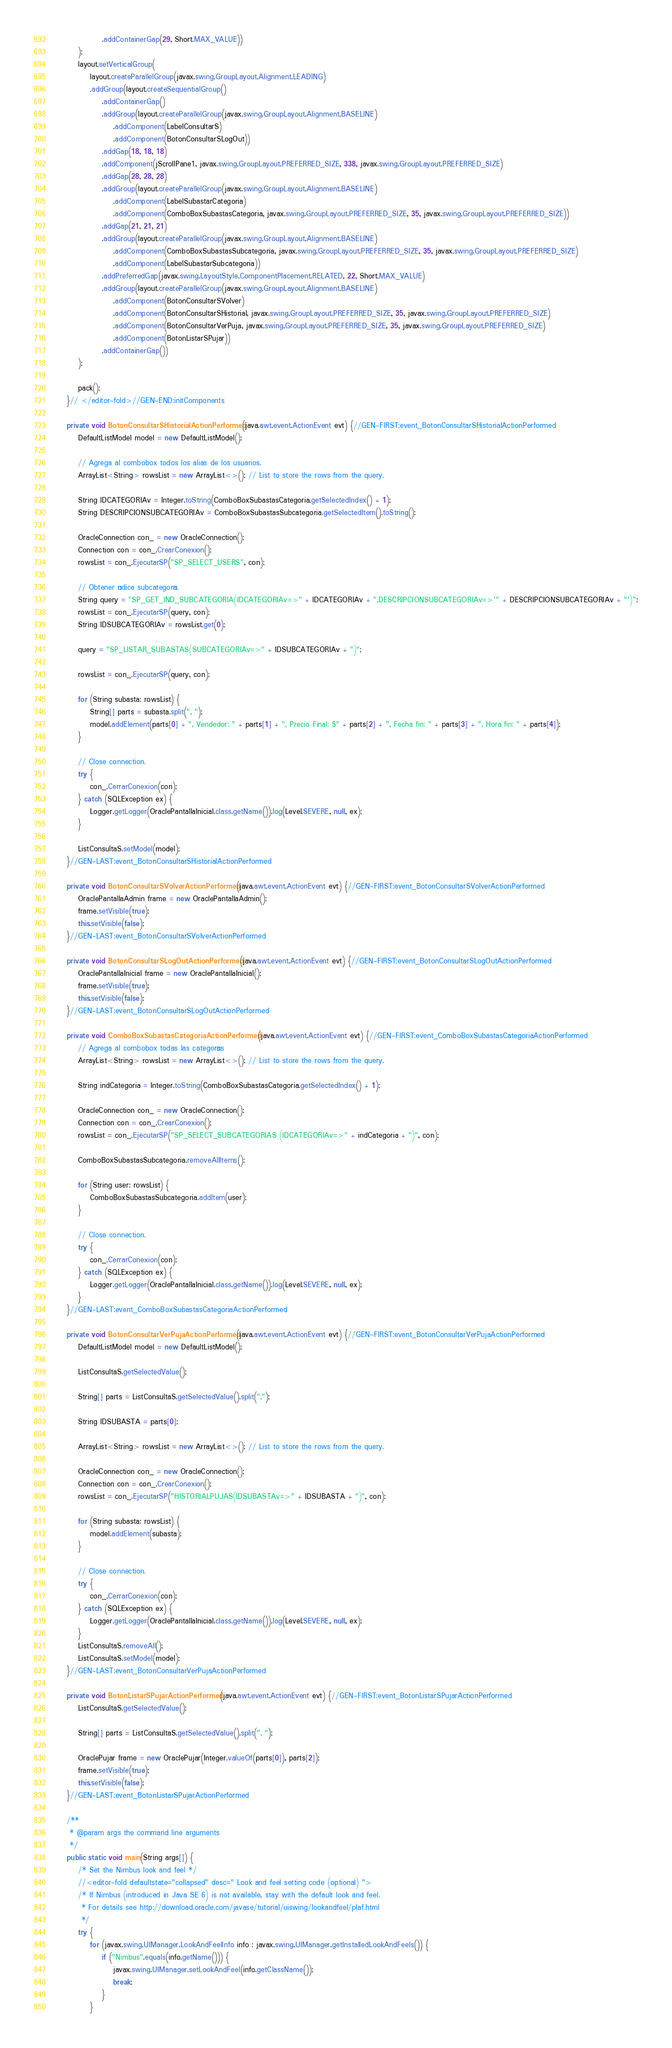Convert code to text. <code><loc_0><loc_0><loc_500><loc_500><_Java_>                .addContainerGap(29, Short.MAX_VALUE))
        );
        layout.setVerticalGroup(
            layout.createParallelGroup(javax.swing.GroupLayout.Alignment.LEADING)
            .addGroup(layout.createSequentialGroup()
                .addContainerGap()
                .addGroup(layout.createParallelGroup(javax.swing.GroupLayout.Alignment.BASELINE)
                    .addComponent(LabelConsultarS)
                    .addComponent(BotonConsultarSLogOut))
                .addGap(18, 18, 18)
                .addComponent(jScrollPane1, javax.swing.GroupLayout.PREFERRED_SIZE, 338, javax.swing.GroupLayout.PREFERRED_SIZE)
                .addGap(28, 28, 28)
                .addGroup(layout.createParallelGroup(javax.swing.GroupLayout.Alignment.BASELINE)
                    .addComponent(LabelSubastarCategoria)
                    .addComponent(ComboBoxSubastasCategoria, javax.swing.GroupLayout.PREFERRED_SIZE, 35, javax.swing.GroupLayout.PREFERRED_SIZE))
                .addGap(21, 21, 21)
                .addGroup(layout.createParallelGroup(javax.swing.GroupLayout.Alignment.BASELINE)
                    .addComponent(ComboBoxSubastasSubcategoria, javax.swing.GroupLayout.PREFERRED_SIZE, 35, javax.swing.GroupLayout.PREFERRED_SIZE)
                    .addComponent(LabelSubastarSubcategoria))
                .addPreferredGap(javax.swing.LayoutStyle.ComponentPlacement.RELATED, 22, Short.MAX_VALUE)
                .addGroup(layout.createParallelGroup(javax.swing.GroupLayout.Alignment.BASELINE)
                    .addComponent(BotonConsultarSVolver)
                    .addComponent(BotonConsultarSHistorial, javax.swing.GroupLayout.PREFERRED_SIZE, 35, javax.swing.GroupLayout.PREFERRED_SIZE)
                    .addComponent(BotonConsultarVerPuja, javax.swing.GroupLayout.PREFERRED_SIZE, 35, javax.swing.GroupLayout.PREFERRED_SIZE)
                    .addComponent(BotonListarSPujar))
                .addContainerGap())
        );

        pack();
    }// </editor-fold>//GEN-END:initComponents

    private void BotonConsultarSHistorialActionPerformed(java.awt.event.ActionEvent evt) {//GEN-FIRST:event_BotonConsultarSHistorialActionPerformed
        DefaultListModel model = new DefaultListModel();
        
        // Agrega al combobox todos los alias de los usuarios.
        ArrayList<String> rowsList = new ArrayList<>(); // List to store the rows from the query.
        
        String IDCATEGORIAv = Integer.toString(ComboBoxSubastasCategoria.getSelectedIndex() + 1);
        String DESCRIPCIONSUBCATEGORIAv = ComboBoxSubastasSubcategoria.getSelectedItem().toString();
        
        OracleConnection con_ = new OracleConnection();
        Connection con = con_.CrearConexion();
        rowsList = con_.EjecutarSP("SP_SELECT_USERS", con);
        
        // Obtener índice subcategoría.
        String query = "SP_GET_IND_SUBCATEGORIA(IDCATEGORIAv=>" + IDCATEGORIAv + ",DESCRIPCIONSUBCATEGORIAv=>'" + DESCRIPCIONSUBCATEGORIAv + "')";
        rowsList = con_.EjecutarSP(query, con);
        String IDSUBCATEGORIAv = rowsList.get(0);
        
        query = "SP_LISTAR_SUBASTAS(SUBCATEGORIAv=>" + IDSUBCATEGORIAv + ")";
 
        rowsList = con_.EjecutarSP(query, con);
        
        for (String subasta: rowsList) {
            String[] parts = subasta.split(", ");
            model.addElement(parts[0] + ", Vendedor: " + parts[1] + ", Precio Final: $" + parts[2] + ", Fecha fin: " + parts[3] + ", Hora fin: " + parts[4]);
        }
        
        // Close connection.
        try {
            con_.CerrarConexion(con);
        } catch (SQLException ex) {
            Logger.getLogger(OraclePantallaInicial.class.getName()).log(Level.SEVERE, null, ex);
        }
        
        ListConsultaS.setModel(model);
    }//GEN-LAST:event_BotonConsultarSHistorialActionPerformed

    private void BotonConsultarSVolverActionPerformed(java.awt.event.ActionEvent evt) {//GEN-FIRST:event_BotonConsultarSVolverActionPerformed
        OraclePantallaAdmin frame = new OraclePantallaAdmin();
        frame.setVisible(true);
        this.setVisible(false);
    }//GEN-LAST:event_BotonConsultarSVolverActionPerformed

    private void BotonConsultarSLogOutActionPerformed(java.awt.event.ActionEvent evt) {//GEN-FIRST:event_BotonConsultarSLogOutActionPerformed
        OraclePantallaInicial frame = new OraclePantallaInicial();
        frame.setVisible(true);
        this.setVisible(false);
    }//GEN-LAST:event_BotonConsultarSLogOutActionPerformed

    private void ComboBoxSubastasCategoriaActionPerformed(java.awt.event.ActionEvent evt) {//GEN-FIRST:event_ComboBoxSubastasCategoriaActionPerformed
        // Agrega al combobox todas las categorías
        ArrayList<String> rowsList = new ArrayList<>(); // List to store the rows from the query.

        String indCategoria = Integer.toString(ComboBoxSubastasCategoria.getSelectedIndex() + 1);

        OracleConnection con_ = new OracleConnection();
        Connection con = con_.CrearConexion();
        rowsList = con_.EjecutarSP("SP_SELECT_SUBCATEGORIAS (IDCATEGORIAv=>" + indCategoria + ")", con);

        ComboBoxSubastasSubcategoria.removeAllItems();

        for (String user: rowsList) {
            ComboBoxSubastasSubcategoria.addItem(user);
        }

        // Close connection.
        try {
            con_.CerrarConexion(con);
        } catch (SQLException ex) {
            Logger.getLogger(OraclePantallaInicial.class.getName()).log(Level.SEVERE, null, ex);
        }
    }//GEN-LAST:event_ComboBoxSubastasCategoriaActionPerformed

    private void BotonConsultarVerPujaActionPerformed(java.awt.event.ActionEvent evt) {//GEN-FIRST:event_BotonConsultarVerPujaActionPerformed
        DefaultListModel model = new DefaultListModel();
        
        ListConsultaS.getSelectedValue();
        
        String[] parts = ListConsultaS.getSelectedValue().split(",");
        
        String IDSUBASTA = parts[0];
        
        ArrayList<String> rowsList = new ArrayList<>(); // List to store the rows from the query.
        
        OracleConnection con_ = new OracleConnection();
        Connection con = con_.CrearConexion();
        rowsList = con_.EjecutarSP("HISTORIALPUJAS(IDSUBASTAv=>" + IDSUBASTA + ")", con);
        
        for (String subasta: rowsList) {
            model.addElement(subasta);
        }
        
        // Close connection.
        try {
            con_.CerrarConexion(con);
        } catch (SQLException ex) {
            Logger.getLogger(OraclePantallaInicial.class.getName()).log(Level.SEVERE, null, ex);
        }
        ListConsultaS.removeAll();
        ListConsultaS.setModel(model);
    }//GEN-LAST:event_BotonConsultarVerPujaActionPerformed

    private void BotonListarSPujarActionPerformed(java.awt.event.ActionEvent evt) {//GEN-FIRST:event_BotonListarSPujarActionPerformed
        ListConsultaS.getSelectedValue();

        String[] parts = ListConsultaS.getSelectedValue().split(", ");

        OraclePujar frame = new OraclePujar(Integer.valueOf(parts[0]), parts[2]);
        frame.setVisible(true);
        this.setVisible(false);
    }//GEN-LAST:event_BotonListarSPujarActionPerformed

    /**
     * @param args the command line arguments
     */
    public static void main(String args[]) {
        /* Set the Nimbus look and feel */
        //<editor-fold defaultstate="collapsed" desc=" Look and feel setting code (optional) ">
        /* If Nimbus (introduced in Java SE 6) is not available, stay with the default look and feel.
         * For details see http://download.oracle.com/javase/tutorial/uiswing/lookandfeel/plaf.html 
         */
        try {
            for (javax.swing.UIManager.LookAndFeelInfo info : javax.swing.UIManager.getInstalledLookAndFeels()) {
                if ("Nimbus".equals(info.getName())) {
                    javax.swing.UIManager.setLookAndFeel(info.getClassName());
                    break;
                }
            }</code> 